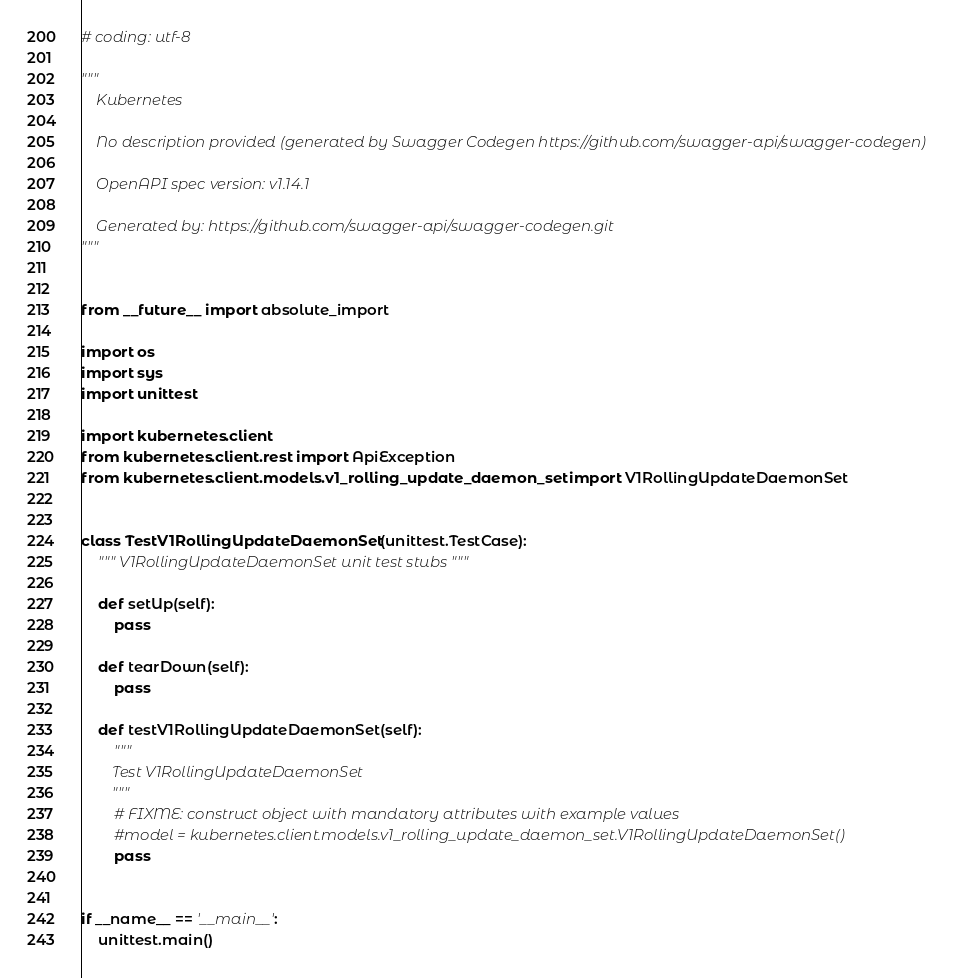<code> <loc_0><loc_0><loc_500><loc_500><_Python_># coding: utf-8

"""
    Kubernetes

    No description provided (generated by Swagger Codegen https://github.com/swagger-api/swagger-codegen)

    OpenAPI spec version: v1.14.1
    
    Generated by: https://github.com/swagger-api/swagger-codegen.git
"""


from __future__ import absolute_import

import os
import sys
import unittest

import kubernetes.client
from kubernetes.client.rest import ApiException
from kubernetes.client.models.v1_rolling_update_daemon_set import V1RollingUpdateDaemonSet


class TestV1RollingUpdateDaemonSet(unittest.TestCase):
    """ V1RollingUpdateDaemonSet unit test stubs """

    def setUp(self):
        pass

    def tearDown(self):
        pass

    def testV1RollingUpdateDaemonSet(self):
        """
        Test V1RollingUpdateDaemonSet
        """
        # FIXME: construct object with mandatory attributes with example values
        #model = kubernetes.client.models.v1_rolling_update_daemon_set.V1RollingUpdateDaemonSet()
        pass


if __name__ == '__main__':
    unittest.main()
</code> 